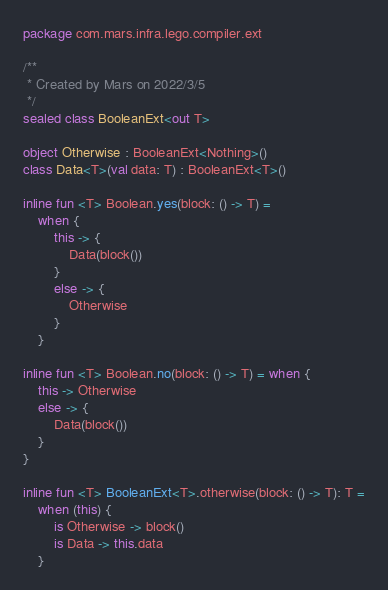<code> <loc_0><loc_0><loc_500><loc_500><_Kotlin_>package com.mars.infra.lego.compiler.ext

/**
 * Created by Mars on 2022/3/5
 */
sealed class BooleanExt<out T>

object Otherwise : BooleanExt<Nothing>()
class Data<T>(val data: T) : BooleanExt<T>()

inline fun <T> Boolean.yes(block: () -> T) =
    when {
        this -> {
            Data(block())
        }
        else -> {
            Otherwise
        }
    }

inline fun <T> Boolean.no(block: () -> T) = when {
    this -> Otherwise
    else -> {
        Data(block())
    }
}

inline fun <T> BooleanExt<T>.otherwise(block: () -> T): T =
    when (this) {
        is Otherwise -> block()
        is Data -> this.data
    }</code> 